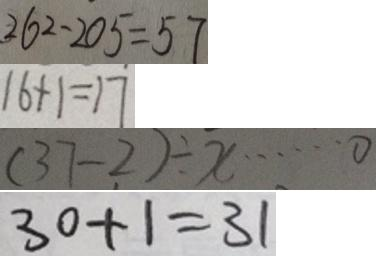<formula> <loc_0><loc_0><loc_500><loc_500>2 6 2 - 2 0 5 = 5 7 
 1 6 + 1 = 1 7 
 ( 3 7 - 2 ) \div x \cdots 0 
 3 0 + 1 = 3 1</formula> 